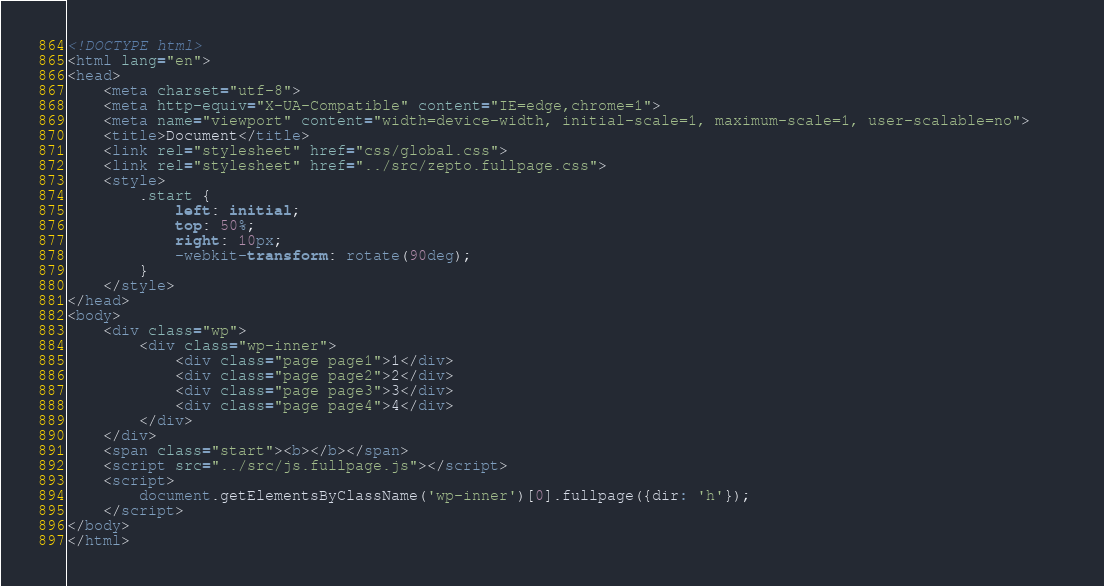<code> <loc_0><loc_0><loc_500><loc_500><_HTML_><!DOCTYPE html>
<html lang="en">
<head>
    <meta charset="utf-8">
    <meta http-equiv="X-UA-Compatible" content="IE=edge,chrome=1">
    <meta name="viewport" content="width=device-width, initial-scale=1, maximum-scale=1, user-scalable=no">    
    <title>Document</title>
    <link rel="stylesheet" href="css/global.css">
    <link rel="stylesheet" href="../src/zepto.fullpage.css">
    <style>
        .start {
            left: initial;
            top: 50%;
            right: 10px;
            -webkit-transform: rotate(90deg);
        }
    </style>
</head>
<body>
    <div class="wp">
        <div class="wp-inner">
            <div class="page page1">1</div>
            <div class="page page2">2</div>
            <div class="page page3">3</div>
            <div class="page page4">4</div>
        </div>
    </div>
    <span class="start"><b></b></span>
    <script src="../src/js.fullpage.js"></script>
    <script>
        document.getElementsByClassName('wp-inner')[0].fullpage({dir: 'h'});
    </script>
</body>
</html></code> 